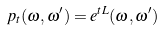<formula> <loc_0><loc_0><loc_500><loc_500>p _ { t } ( \omega , \omega ^ { \prime } ) = e ^ { t L } ( \omega , \omega ^ { \prime } )</formula> 